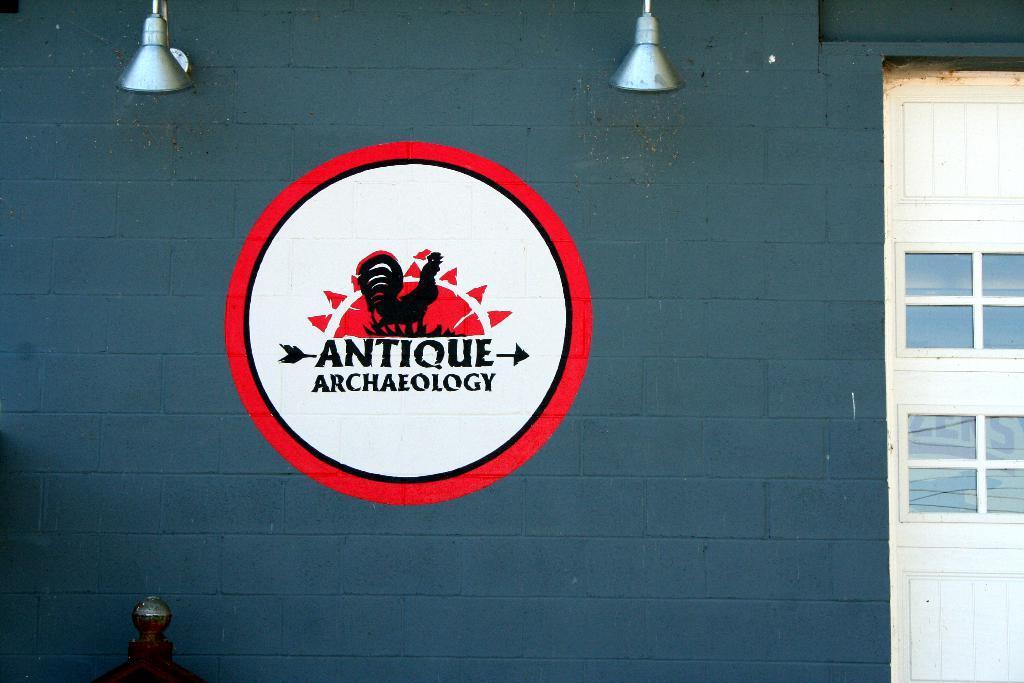Can you describe this image briefly? In this image there is a wall, there are objects on the wall, there are objects truncated towards the top of the image, there is an object truncated towards the bottom of the image, there is a painting on the wall, there is text on the wall, there is a door truncated towards the right of the image. 